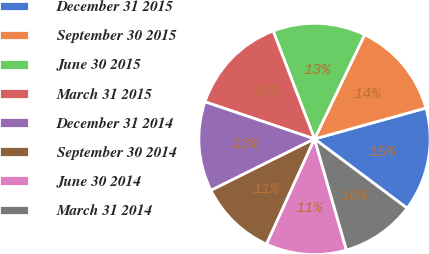Convert chart to OTSL. <chart><loc_0><loc_0><loc_500><loc_500><pie_chart><fcel>December 31 2015<fcel>September 30 2015<fcel>June 30 2015<fcel>March 31 2015<fcel>December 31 2014<fcel>September 30 2014<fcel>June 30 2014<fcel>March 31 2014<nl><fcel>14.53%<fcel>13.56%<fcel>12.96%<fcel>13.98%<fcel>12.54%<fcel>10.85%<fcel>11.27%<fcel>10.32%<nl></chart> 